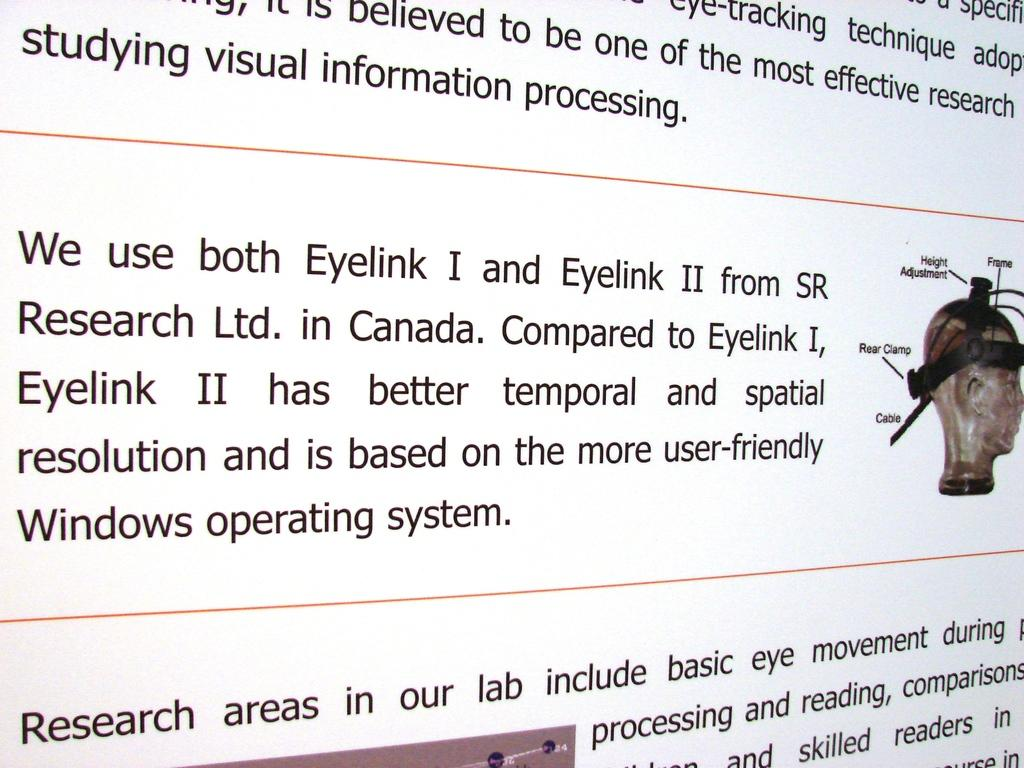What can be seen on the poster in the image? There is a poster in the image, and it contains text. Can you describe the text on the poster? Unfortunately, the specific content of the text cannot be determined from the provided facts. Which direction is the queen facing in the image? There is no queen present in the image, so it is not possible to answer that question. 